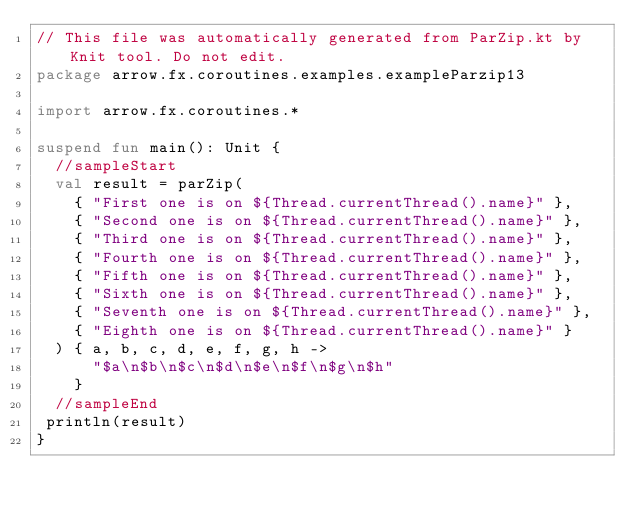Convert code to text. <code><loc_0><loc_0><loc_500><loc_500><_Kotlin_>// This file was automatically generated from ParZip.kt by Knit tool. Do not edit.
package arrow.fx.coroutines.examples.exampleParzip13

import arrow.fx.coroutines.*

suspend fun main(): Unit {
  //sampleStart
  val result = parZip(
    { "First one is on ${Thread.currentThread().name}" },
    { "Second one is on ${Thread.currentThread().name}" },
    { "Third one is on ${Thread.currentThread().name}" },
    { "Fourth one is on ${Thread.currentThread().name}" },
    { "Fifth one is on ${Thread.currentThread().name}" },
    { "Sixth one is on ${Thread.currentThread().name}" },
    { "Seventh one is on ${Thread.currentThread().name}" },
    { "Eighth one is on ${Thread.currentThread().name}" }
  ) { a, b, c, d, e, f, g, h ->
      "$a\n$b\n$c\n$d\n$e\n$f\n$g\n$h"
    }
  //sampleEnd
 println(result)
}
</code> 